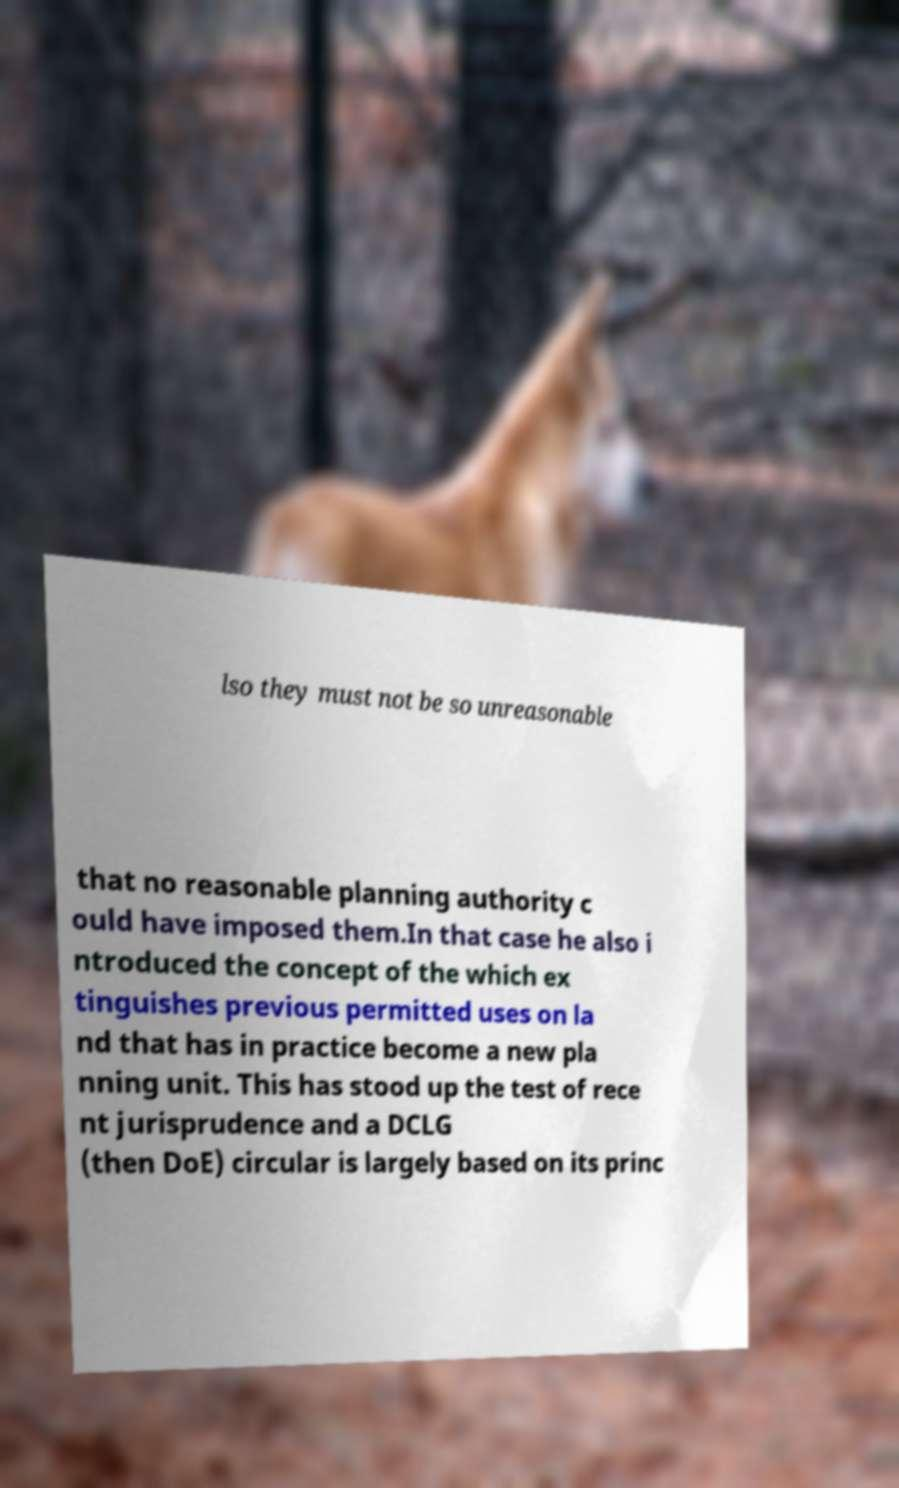Could you extract and type out the text from this image? lso they must not be so unreasonable that no reasonable planning authority c ould have imposed them.In that case he also i ntroduced the concept of the which ex tinguishes previous permitted uses on la nd that has in practice become a new pla nning unit. This has stood up the test of rece nt jurisprudence and a DCLG (then DoE) circular is largely based on its princ 